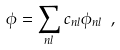<formula> <loc_0><loc_0><loc_500><loc_500>\phi = \sum _ { n l } c _ { n l } \phi _ { n l } \ ,</formula> 